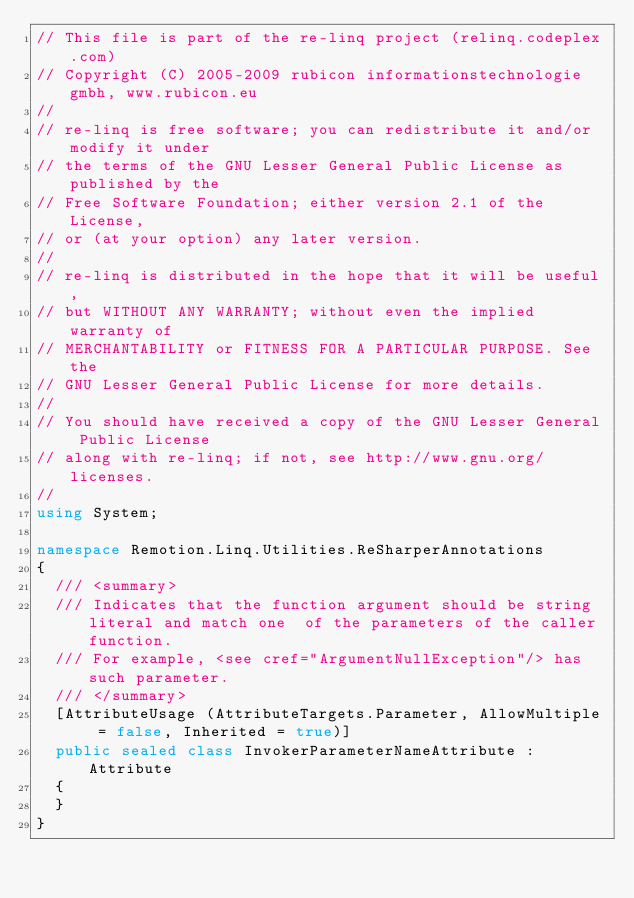Convert code to text. <code><loc_0><loc_0><loc_500><loc_500><_C#_>// This file is part of the re-linq project (relinq.codeplex.com)
// Copyright (C) 2005-2009 rubicon informationstechnologie gmbh, www.rubicon.eu
// 
// re-linq is free software; you can redistribute it and/or modify it under 
// the terms of the GNU Lesser General Public License as published by the 
// Free Software Foundation; either version 2.1 of the License, 
// or (at your option) any later version.
// 
// re-linq is distributed in the hope that it will be useful, 
// but WITHOUT ANY WARRANTY; without even the implied warranty of 
// MERCHANTABILITY or FITNESS FOR A PARTICULAR PURPOSE. See the 
// GNU Lesser General Public License for more details.
// 
// You should have received a copy of the GNU Lesser General Public License
// along with re-linq; if not, see http://www.gnu.org/licenses.
// 
using System;

namespace Remotion.Linq.Utilities.ReSharperAnnotations
{
  /// <summary>
  /// Indicates that the function argument should be string literal and match one  of the parameters of the caller function.
  /// For example, <see cref="ArgumentNullException"/> has such parameter.
  /// </summary>
  [AttributeUsage (AttributeTargets.Parameter, AllowMultiple = false, Inherited = true)]
  public sealed class InvokerParameterNameAttribute : Attribute
  {
  }
}</code> 